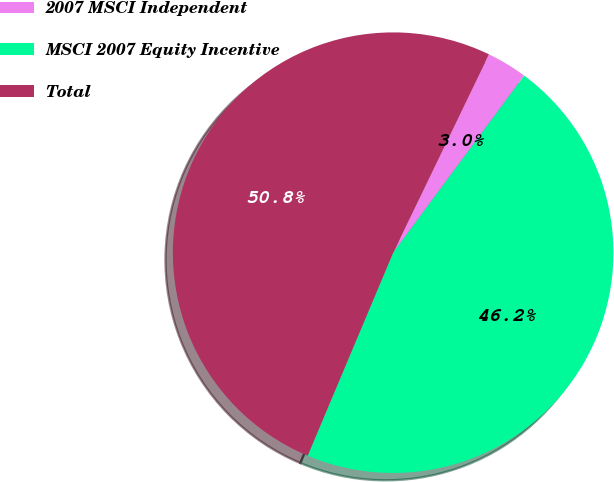<chart> <loc_0><loc_0><loc_500><loc_500><pie_chart><fcel>2007 MSCI Independent<fcel>MSCI 2007 Equity Incentive<fcel>Total<nl><fcel>2.98%<fcel>46.2%<fcel>50.82%<nl></chart> 